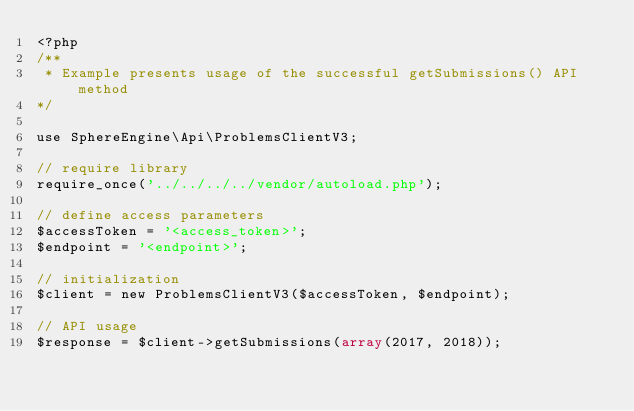<code> <loc_0><loc_0><loc_500><loc_500><_PHP_><?php
/**
 * Example presents usage of the successful getSubmissions() API method
*/

use SphereEngine\Api\ProblemsClientV3;

// require library
require_once('../../../../vendor/autoload.php');

// define access parameters
$accessToken = '<access_token>';
$endpoint = '<endpoint>';

// initialization
$client = new ProblemsClientV3($accessToken, $endpoint);

// API usage
$response = $client->getSubmissions(array(2017, 2018));
</code> 